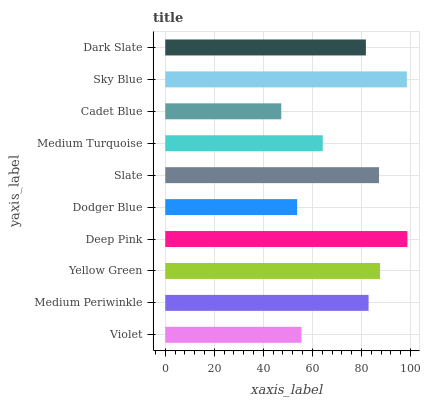Is Cadet Blue the minimum?
Answer yes or no. Yes. Is Deep Pink the maximum?
Answer yes or no. Yes. Is Medium Periwinkle the minimum?
Answer yes or no. No. Is Medium Periwinkle the maximum?
Answer yes or no. No. Is Medium Periwinkle greater than Violet?
Answer yes or no. Yes. Is Violet less than Medium Periwinkle?
Answer yes or no. Yes. Is Violet greater than Medium Periwinkle?
Answer yes or no. No. Is Medium Periwinkle less than Violet?
Answer yes or no. No. Is Medium Periwinkle the high median?
Answer yes or no. Yes. Is Dark Slate the low median?
Answer yes or no. Yes. Is Violet the high median?
Answer yes or no. No. Is Violet the low median?
Answer yes or no. No. 